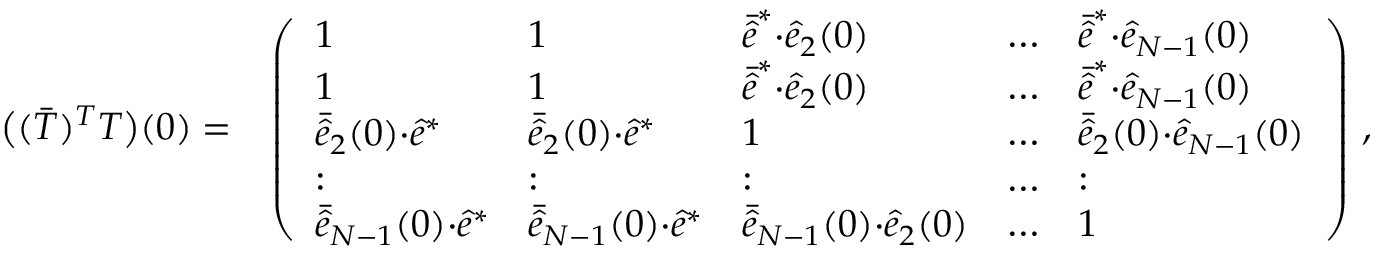<formula> <loc_0><loc_0><loc_500><loc_500>\begin{array} { r l } { \left ( ( \bar { T } ) ^ { T } T \right ) ( 0 ) = } & { \left ( \begin{array} { l l l l l } { 1 } & { 1 } & { \bar { \hat { e } } ^ { * } { \cdot } \hat { e } _ { 2 } ( 0 ) } & { \dots } & { \bar { \hat { e } } ^ { * } { \cdot } \hat { e } _ { N - 1 } ( 0 ) } \\ { 1 } & { 1 } & { \bar { \hat { e } } ^ { * } { \cdot } \hat { e } _ { 2 } ( 0 ) } & { \dots } & { \bar { \hat { e } } ^ { * } { \cdot } \hat { e } _ { N - 1 } ( 0 ) } \\ { \bar { \hat { e } } _ { 2 } ( 0 ) { \cdot } \hat { e } ^ { * } } & { \bar { \hat { e } } _ { 2 } ( 0 ) { \cdot } \hat { e } ^ { * } } & { 1 } & { \dots } & { \bar { \hat { e } } _ { 2 } ( 0 ) { \cdot } \hat { e } _ { N - 1 } ( 0 ) } \\ { \colon } & { \colon } & { \colon } & { \dots } & { \colon } \\ { \bar { \hat { e } } _ { N - 1 } ( 0 ) { \cdot } \hat { e } ^ { * } } & { \bar { \hat { e } } _ { N - 1 } ( 0 ) { \cdot } \hat { e } ^ { * } } & { \bar { \hat { e } } _ { N - 1 } ( 0 ) { \cdot } \hat { e } _ { 2 } ( 0 ) } & { \dots } & { 1 } \end{array} \right ) \, , } \end{array}</formula> 